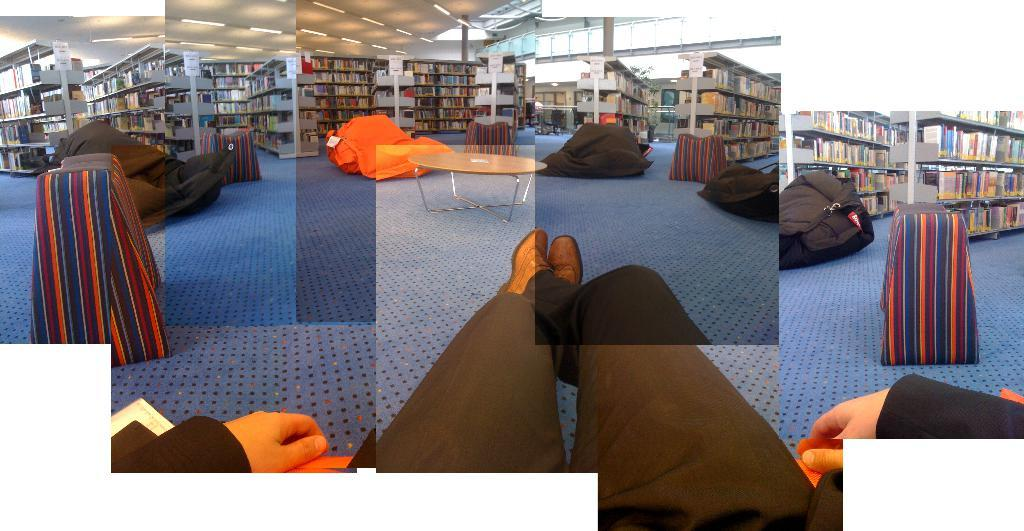What is the man in the image doing? The man is sitting in the image. What type of clothing is the man wearing on his lower body? The man is wearing trousers. What type of footwear is the man wearing? The man is wearing shoes. What type of location is depicted in the image? There is a library in the image. What type of items can be found in a library? There are books in the image. What object might the man be using to carry his belongings? There is a bag in the image. What type of furniture is present in the image? There is a table in the image. What type of surface is visible beneath the man? There is a floor in the image. What type of lighting is present in the image? There are many lights visible at the top of the image. How many balls can be seen in the image? There are no balls present in the image. Is there a girl sitting next to the man in the image? There is no girl present in the image. 